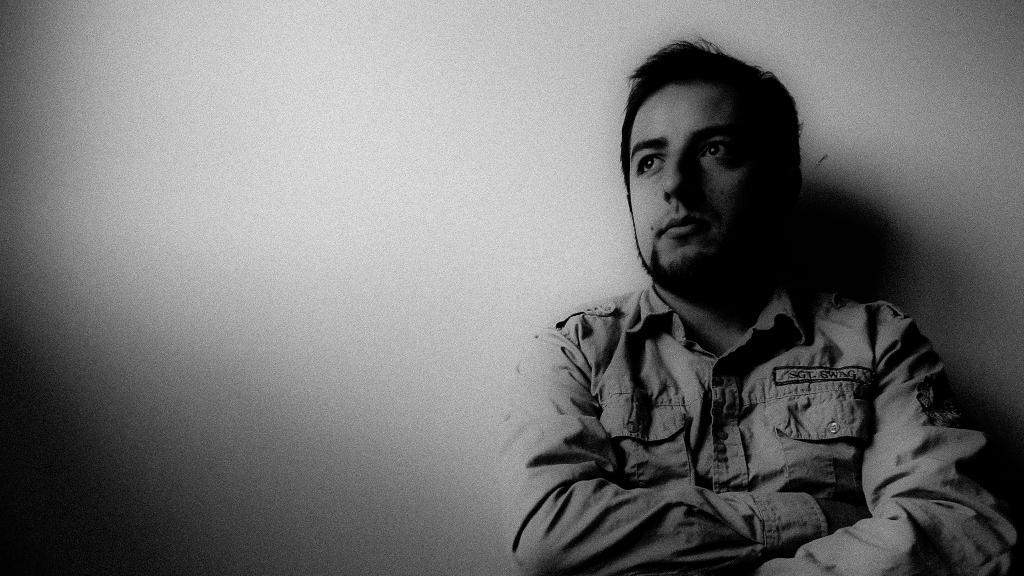What is present in the image? There is a person and a wall in the image. What can be said about the color scheme of the image? The image is in black and white. How much wealth does the person in the image possess? There is no information about the person's wealth in the image. What type of bread can be seen on the table in the image? There is no table or bread present in the image. 